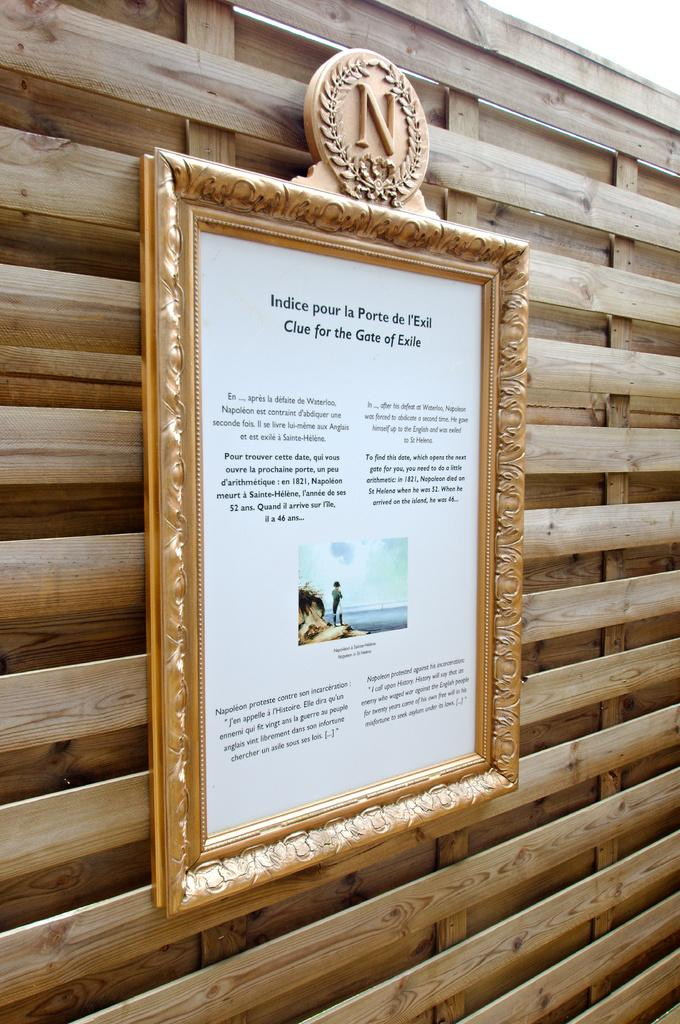<image>
Summarize the visual content of the image. A frame picture on a wooden wall with the letter N on top. 